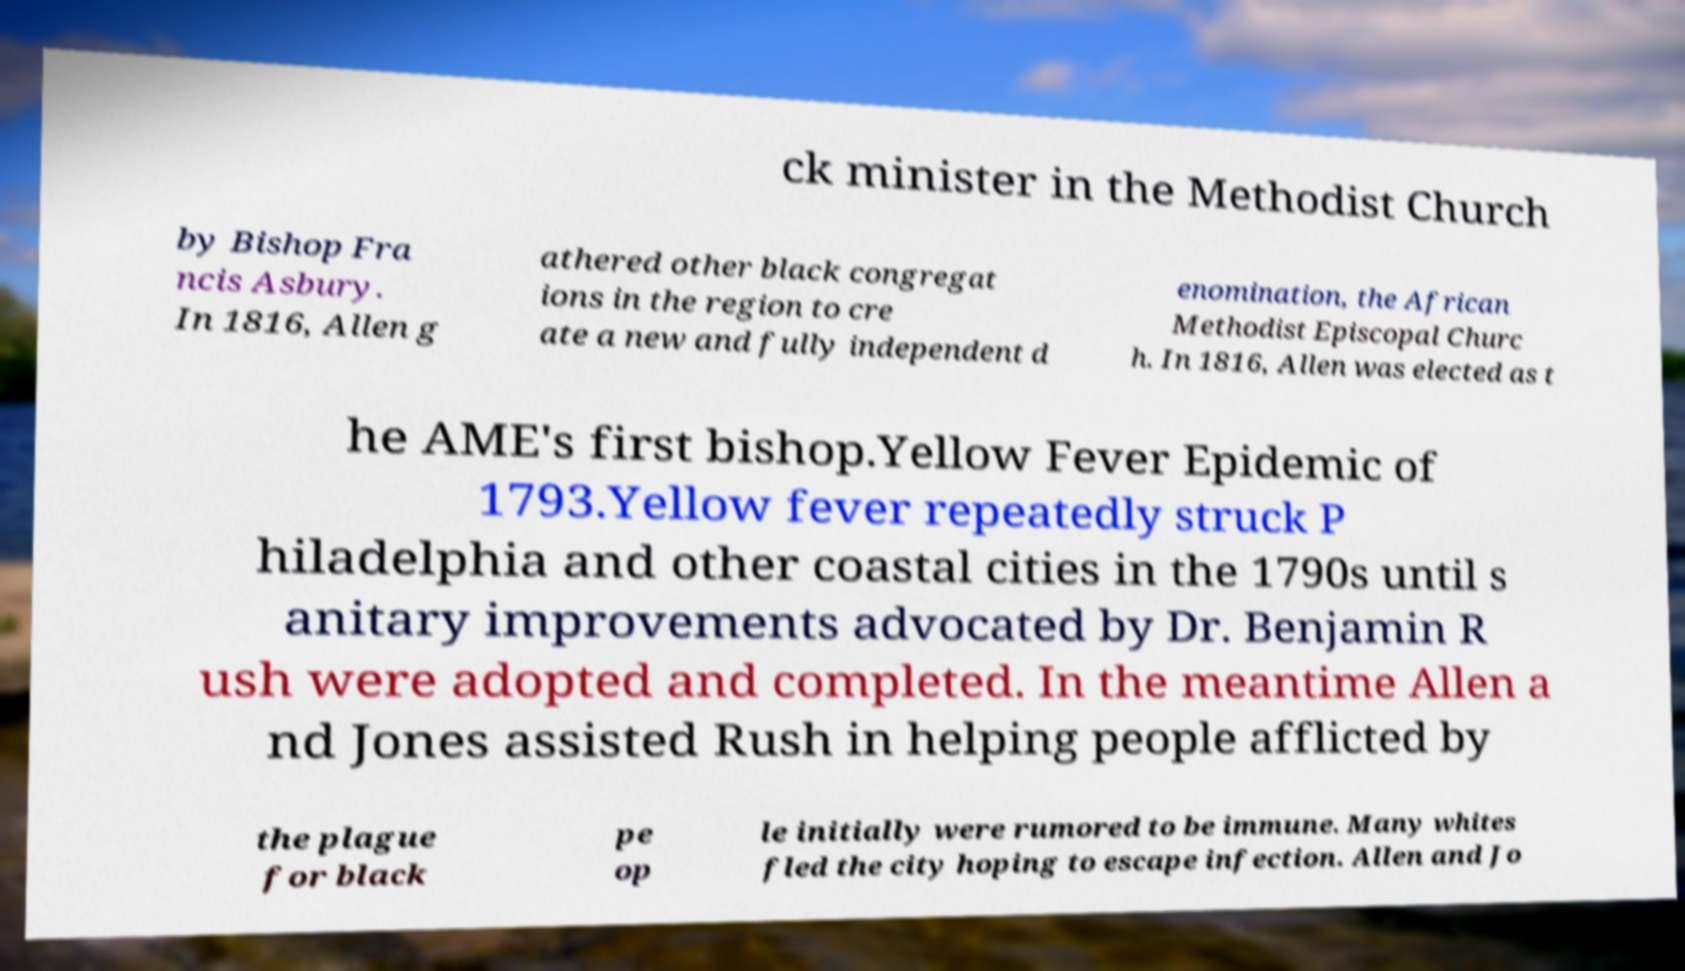There's text embedded in this image that I need extracted. Can you transcribe it verbatim? ck minister in the Methodist Church by Bishop Fra ncis Asbury. In 1816, Allen g athered other black congregat ions in the region to cre ate a new and fully independent d enomination, the African Methodist Episcopal Churc h. In 1816, Allen was elected as t he AME's first bishop.Yellow Fever Epidemic of 1793.Yellow fever repeatedly struck P hiladelphia and other coastal cities in the 1790s until s anitary improvements advocated by Dr. Benjamin R ush were adopted and completed. In the meantime Allen a nd Jones assisted Rush in helping people afflicted by the plague for black pe op le initially were rumored to be immune. Many whites fled the city hoping to escape infection. Allen and Jo 